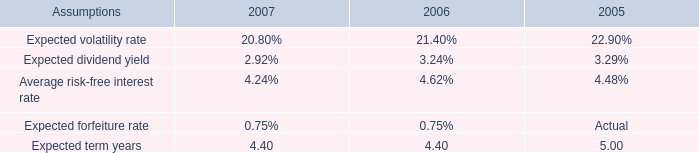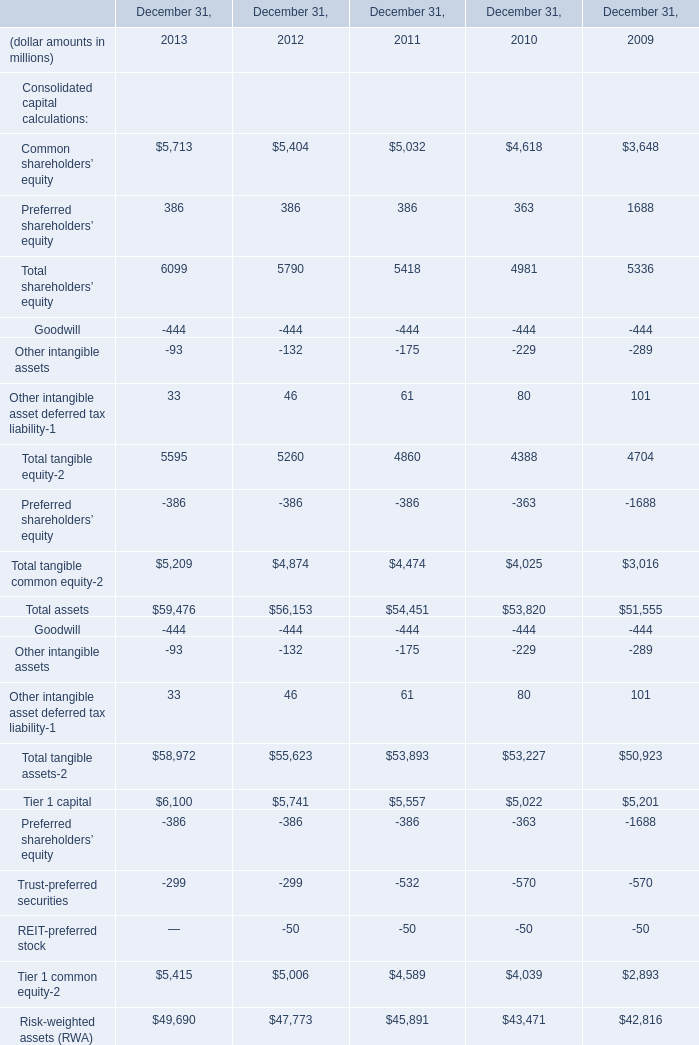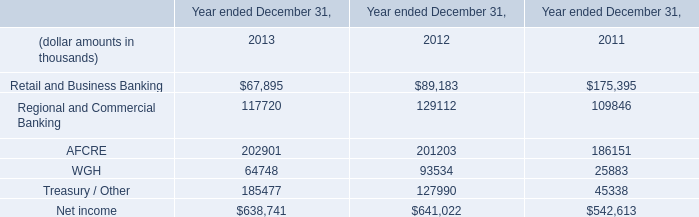What's the average of Preferred shareholders’ equity of December 31, 2009, and WGH of Year ended December 31, 2012 ? 
Computations: ((1688.0 + 93534.0) / 2)
Answer: 47611.0. 